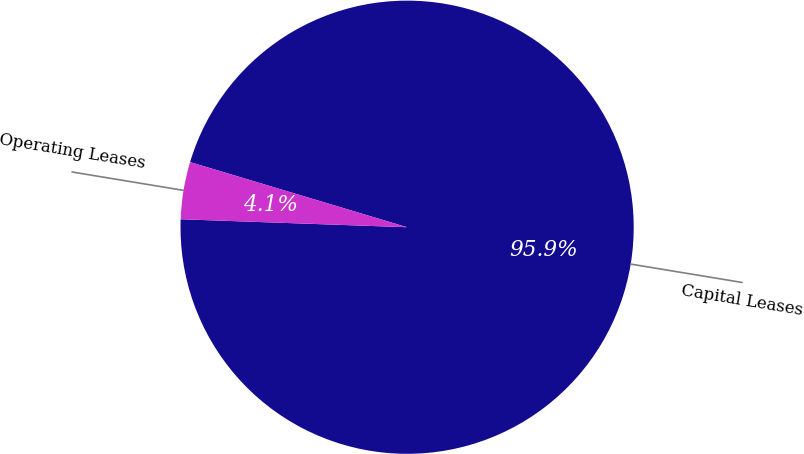Convert chart to OTSL. <chart><loc_0><loc_0><loc_500><loc_500><pie_chart><fcel>Capital Leases<fcel>Operating Leases<nl><fcel>95.92%<fcel>4.08%<nl></chart> 